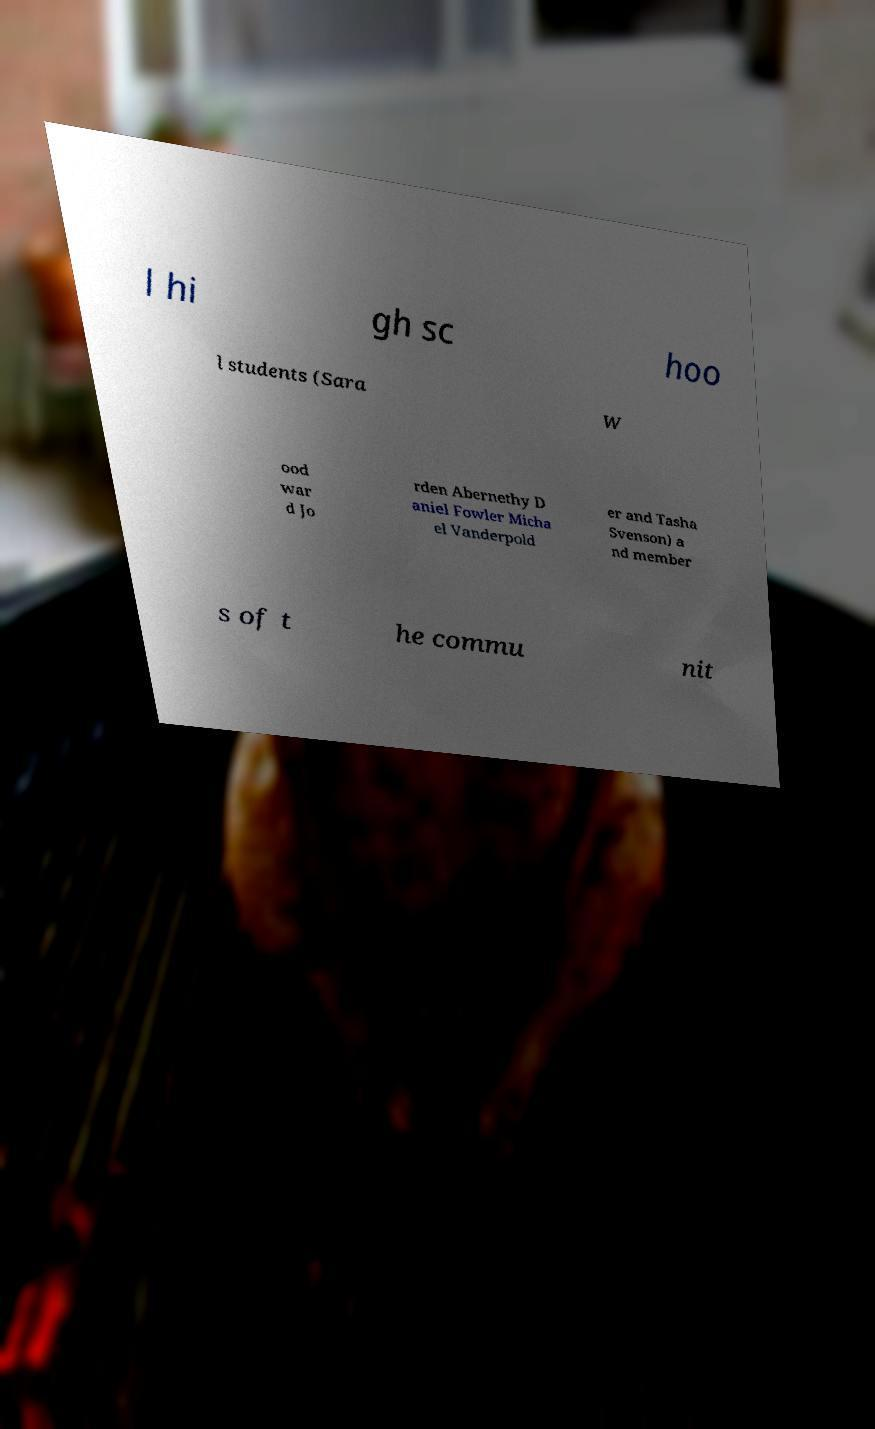Please read and relay the text visible in this image. What does it say? l hi gh sc hoo l students (Sara W ood war d Jo rden Abernethy D aniel Fowler Micha el Vanderpold er and Tasha Svenson) a nd member s of t he commu nit 